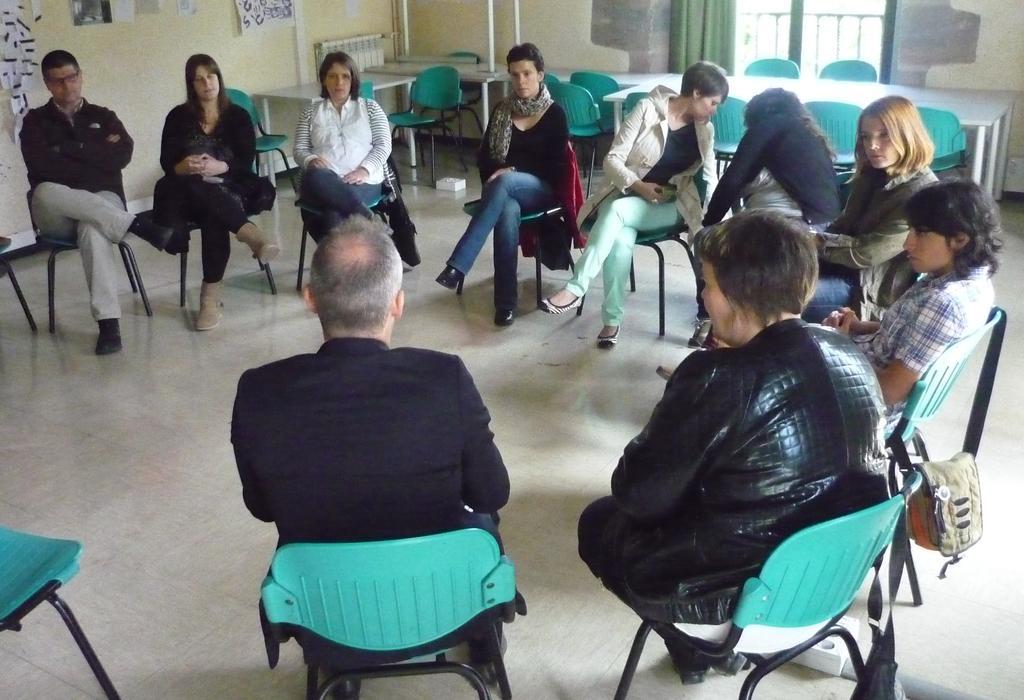Could you give a brief overview of what you see in this image? In this image I can see the group of people siting on the chairs. To the one chair a bag is hanged. In the background there is a window and a curtain to the window. And there are some papers to the wall. 